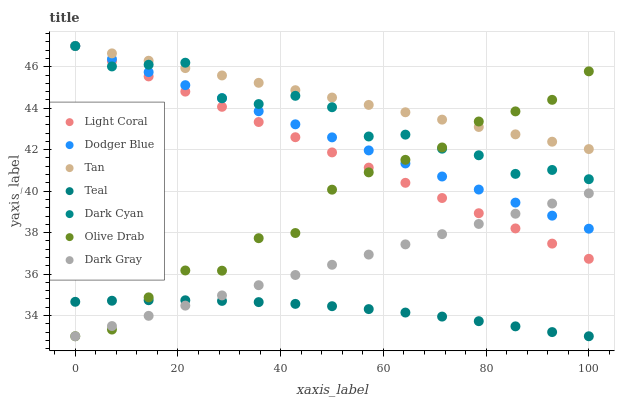Does Teal have the minimum area under the curve?
Answer yes or no. Yes. Does Tan have the maximum area under the curve?
Answer yes or no. Yes. Does Light Coral have the minimum area under the curve?
Answer yes or no. No. Does Light Coral have the maximum area under the curve?
Answer yes or no. No. Is Tan the smoothest?
Answer yes or no. Yes. Is Dark Cyan the roughest?
Answer yes or no. Yes. Is Light Coral the smoothest?
Answer yes or no. No. Is Light Coral the roughest?
Answer yes or no. No. Does Dark Gray have the lowest value?
Answer yes or no. Yes. Does Light Coral have the lowest value?
Answer yes or no. No. Does Tan have the highest value?
Answer yes or no. Yes. Does Teal have the highest value?
Answer yes or no. No. Is Teal less than Light Coral?
Answer yes or no. Yes. Is Tan greater than Teal?
Answer yes or no. Yes. Does Dark Cyan intersect Olive Drab?
Answer yes or no. Yes. Is Dark Cyan less than Olive Drab?
Answer yes or no. No. Is Dark Cyan greater than Olive Drab?
Answer yes or no. No. Does Teal intersect Light Coral?
Answer yes or no. No. 